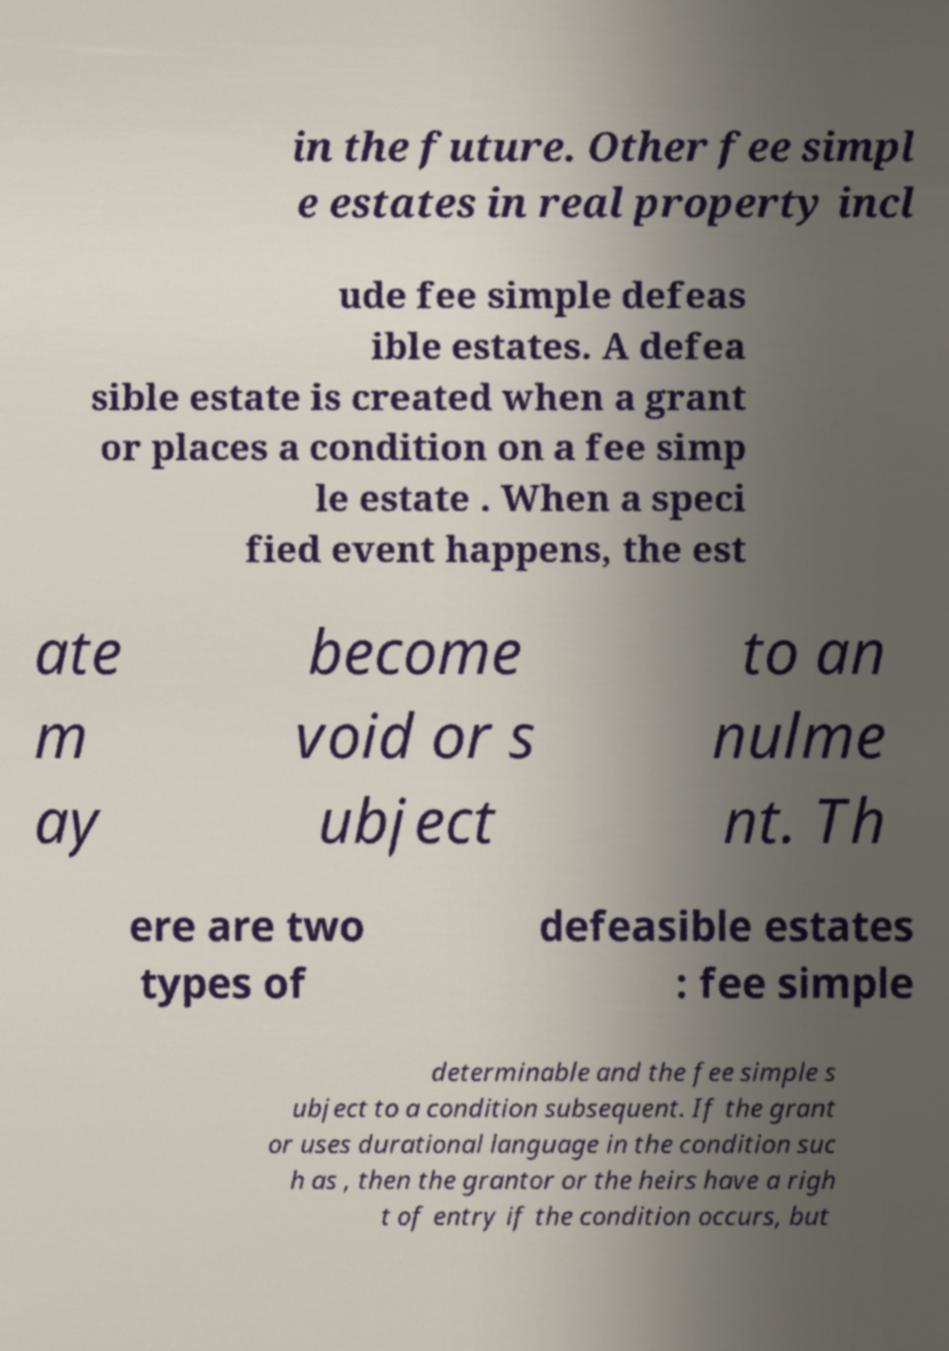What messages or text are displayed in this image? I need them in a readable, typed format. in the future. Other fee simpl e estates in real property incl ude fee simple defeas ible estates. A defea sible estate is created when a grant or places a condition on a fee simp le estate . When a speci fied event happens, the est ate m ay become void or s ubject to an nulme nt. Th ere are two types of defeasible estates : fee simple determinable and the fee simple s ubject to a condition subsequent. If the grant or uses durational language in the condition suc h as , then the grantor or the heirs have a righ t of entry if the condition occurs, but 